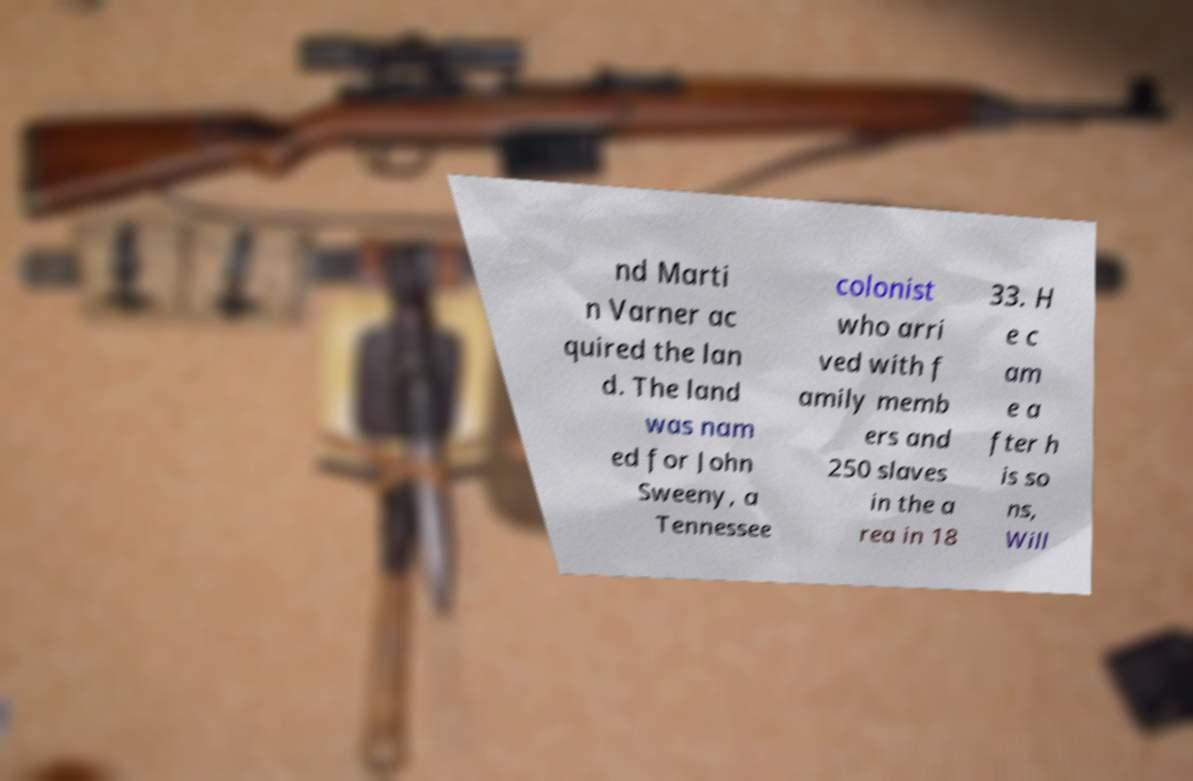Could you assist in decoding the text presented in this image and type it out clearly? nd Marti n Varner ac quired the lan d. The land was nam ed for John Sweeny, a Tennessee colonist who arri ved with f amily memb ers and 250 slaves in the a rea in 18 33. H e c am e a fter h is so ns, Will 